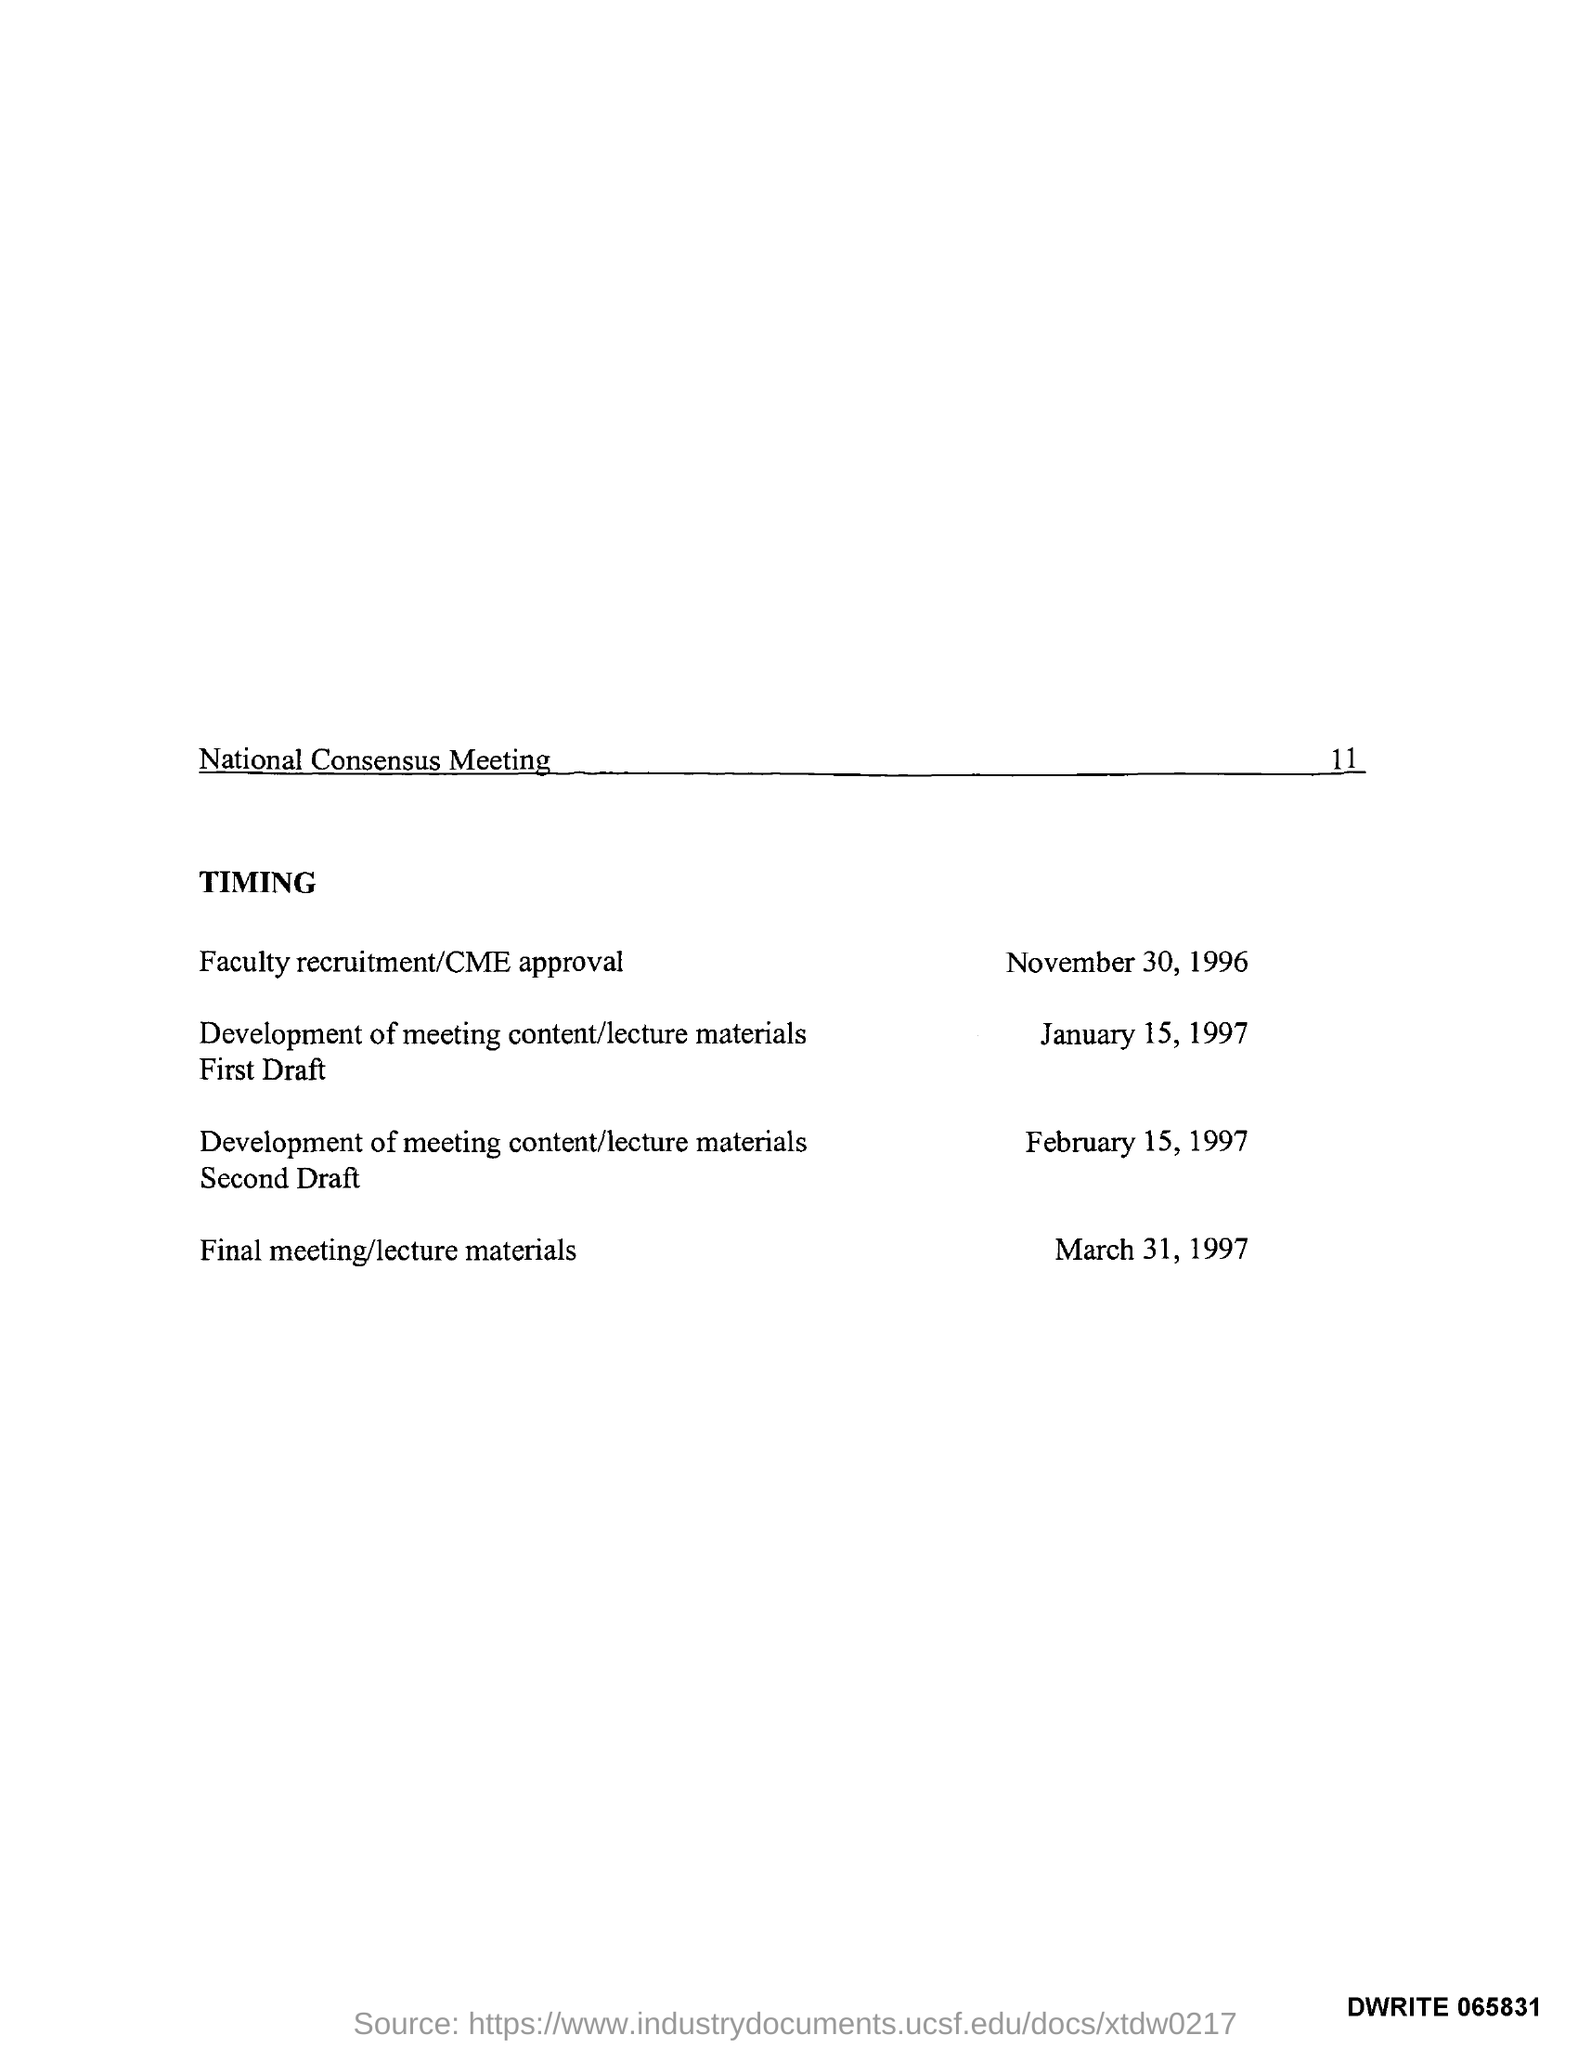Specify some key components in this picture. The page number is 11. 